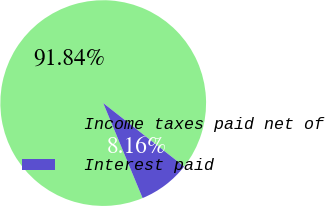Convert chart to OTSL. <chart><loc_0><loc_0><loc_500><loc_500><pie_chart><fcel>Income taxes paid net of<fcel>Interest paid<nl><fcel>91.84%<fcel>8.16%<nl></chart> 